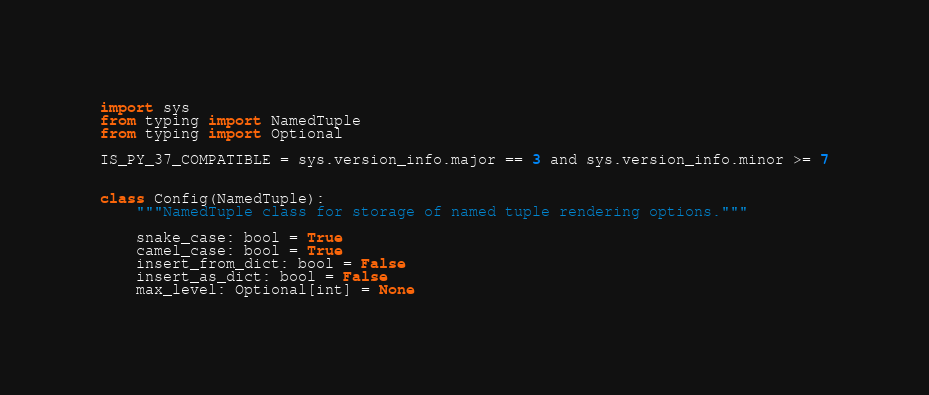Convert code to text. <code><loc_0><loc_0><loc_500><loc_500><_Python_>import sys
from typing import NamedTuple
from typing import Optional

IS_PY_37_COMPATIBLE = sys.version_info.major == 3 and sys.version_info.minor >= 7


class Config(NamedTuple):
    """NamedTuple class for storage of named tuple rendering options."""

    snake_case: bool = True
    camel_case: bool = True
    insert_from_dict: bool = False
    insert_as_dict: bool = False
    max_level: Optional[int] = None
</code> 